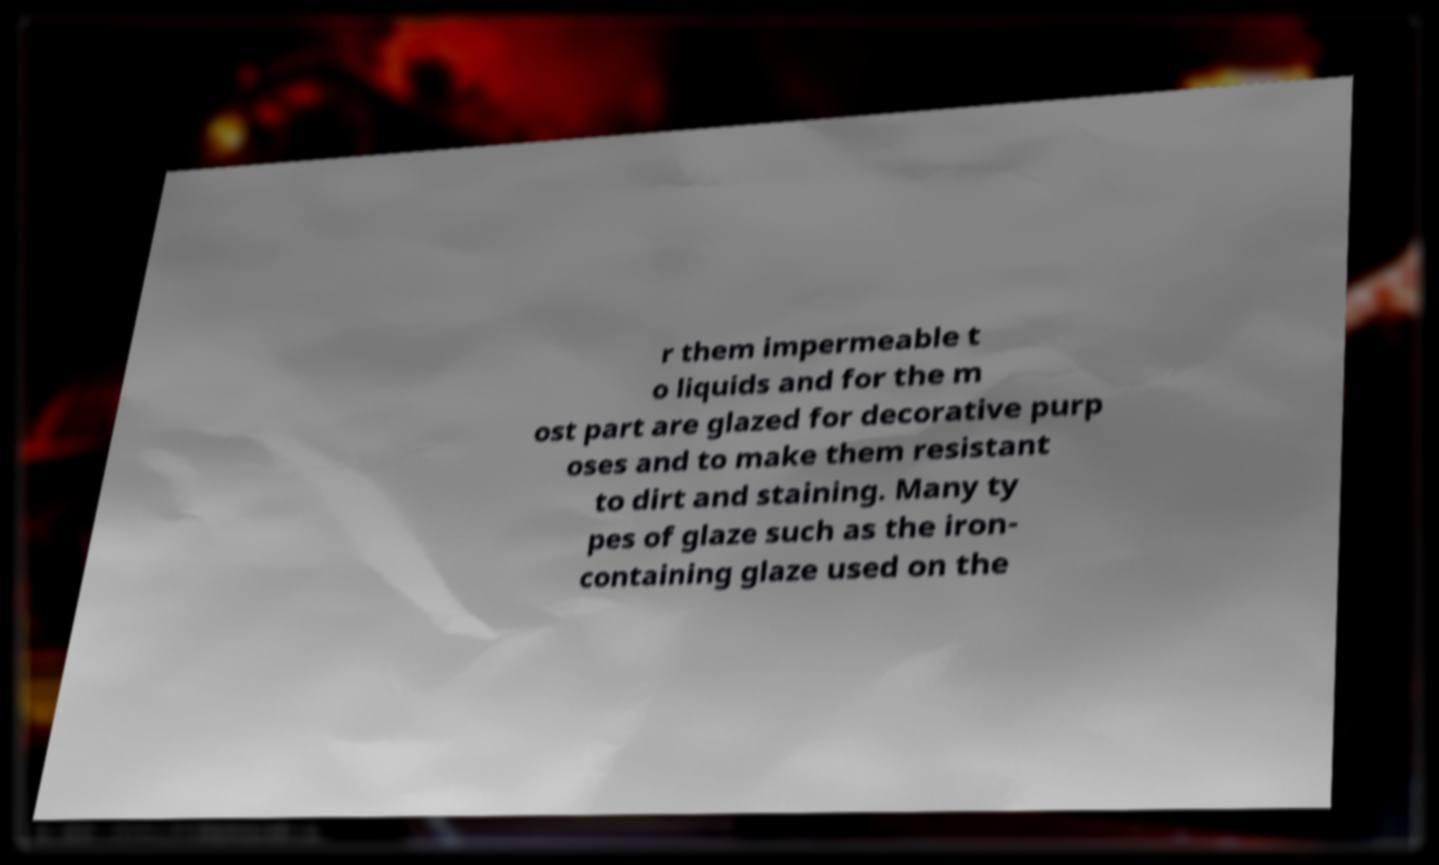For documentation purposes, I need the text within this image transcribed. Could you provide that? r them impermeable t o liquids and for the m ost part are glazed for decorative purp oses and to make them resistant to dirt and staining. Many ty pes of glaze such as the iron- containing glaze used on the 